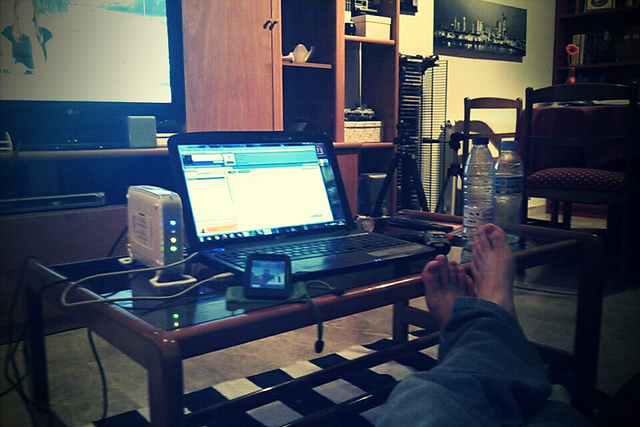<image>What type of footwear is the person wearing? The person is not wearing any footwear. What type of footwear is the person wearing? The person is not wearing any footwear. 